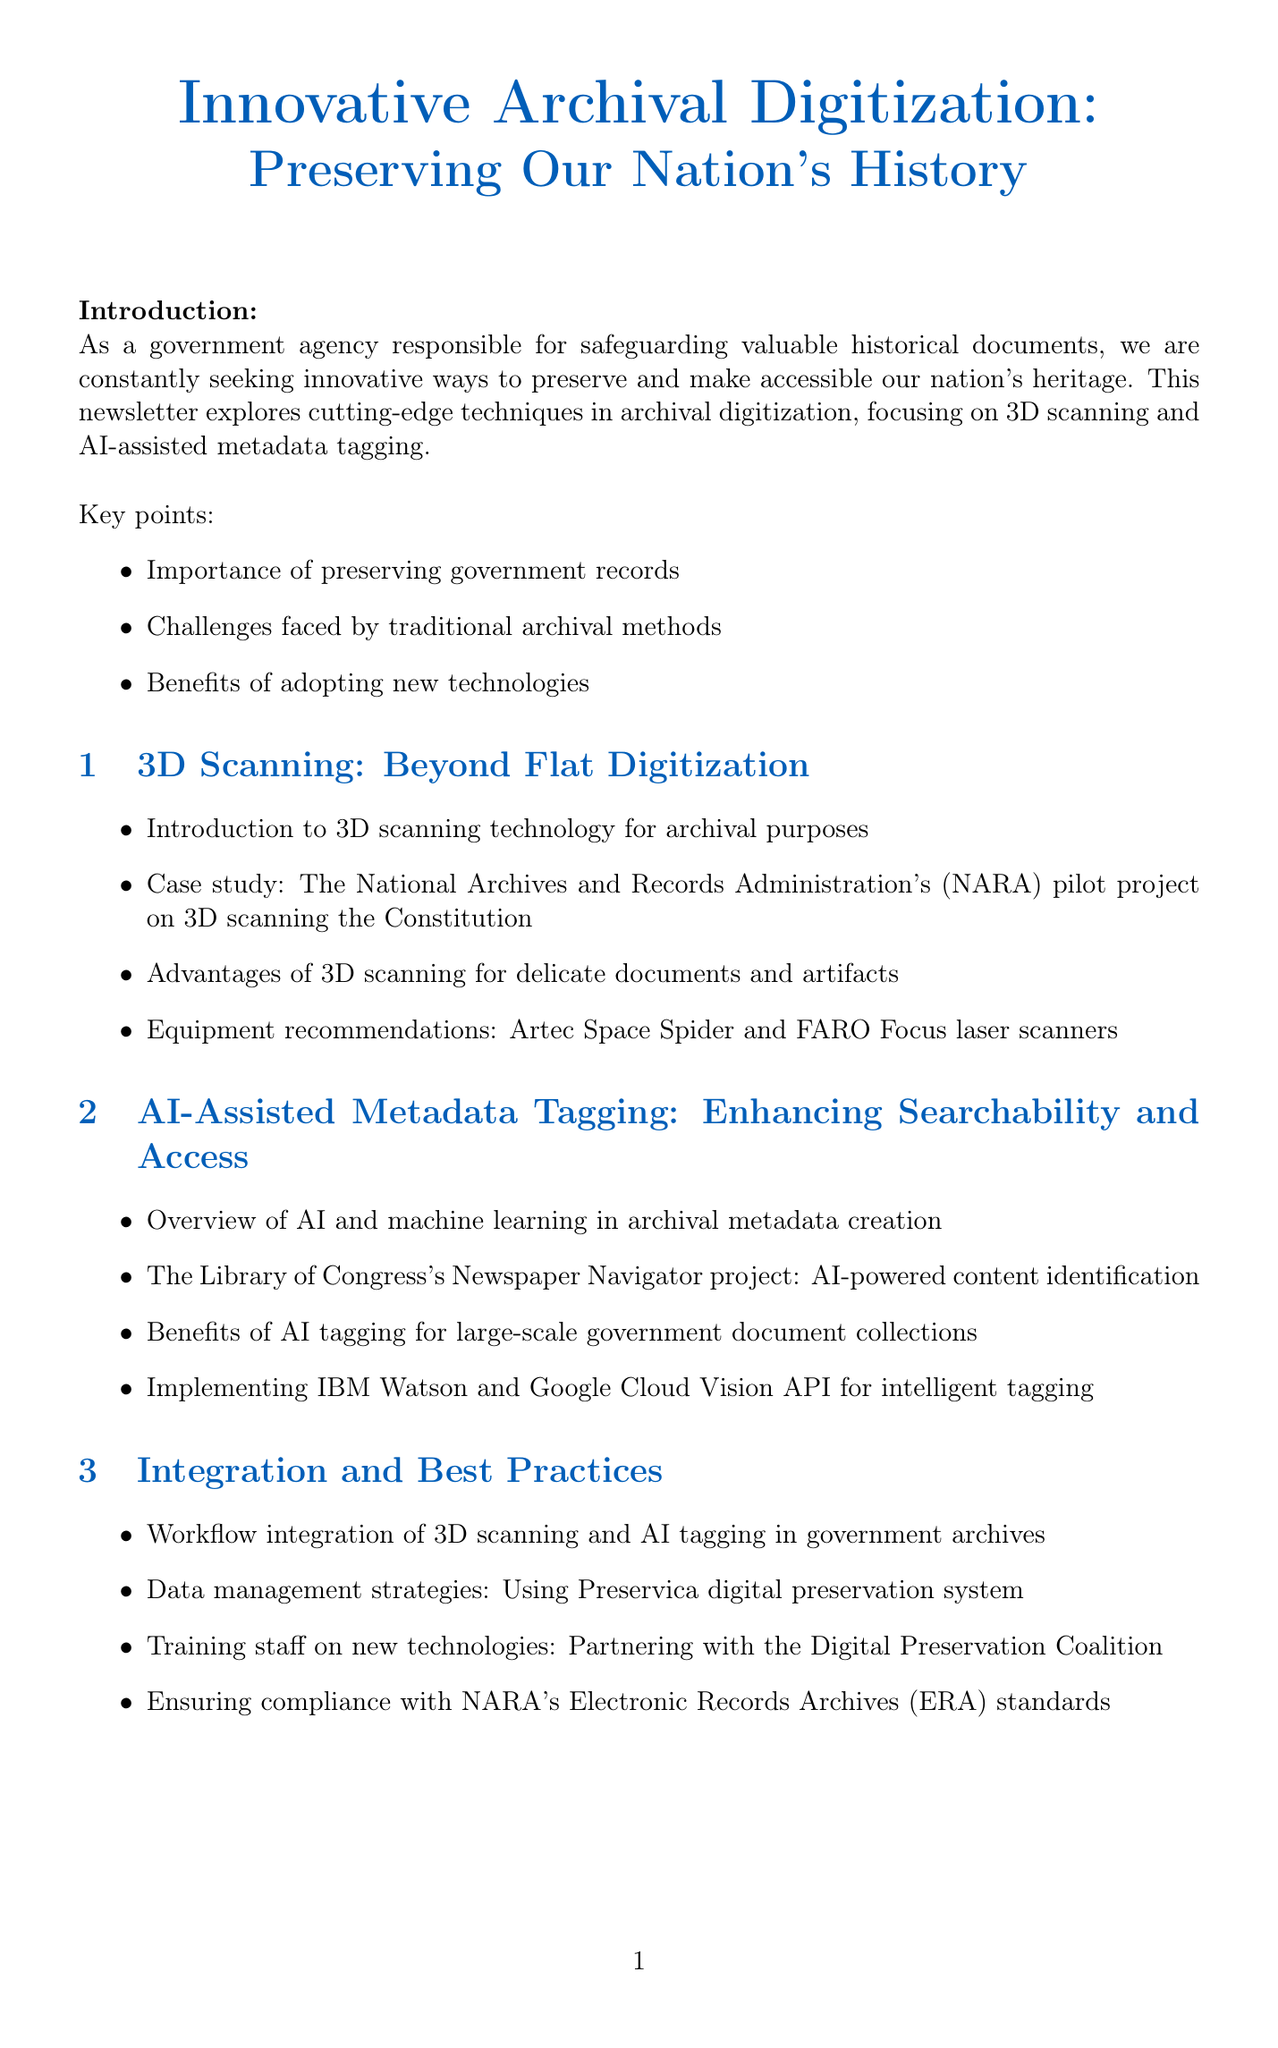What is the title of the newsletter? The title is explicitly mentioned at the beginning of the document.
Answer: Innovative Archival Digitization: Preserving Our Nation's History What are the two main technologies discussed in the newsletter? The introduction highlights the focus on two specific digitization techniques.
Answer: 3D scanning and AI-assisted metadata tagging Which institution conducted a pilot project on 3D scanning the Constitution? The case study in section 1 identifies the institution responsible.
Answer: National Archives and Records Administration What is one of the equipment recommendations for 3D scanning? Section 1 lists equipment options for effective 3D scanning purposes.
Answer: Artec Space Spider What project does the Library of Congress's Newspaper Navigator relate to? Section 2 describes a specific project that utilizes AI for content identification.
Answer: AI-powered content identification What is a key advantage of integrating new technologies into archival management? The conclusion summarizes the benefits of adopting innovative techniques.
Answer: Enhancing ability to preserve and provide access How can government agencies contact for guidance on implementing these technologies? The call to action provides a specific point of contact for assistance.
Answer: Office of the Chief Records Officer What does the Smithsonian Institution’s program focus on? The success story section briefly explains the focus of the Smithsonian’s program.
Answer: 3D digitization efforts Which digital preservation system is mentioned for data management strategies? Section 3 identifies a specific system recommended for managing archival data.
Answer: Preservica digital preservation system 